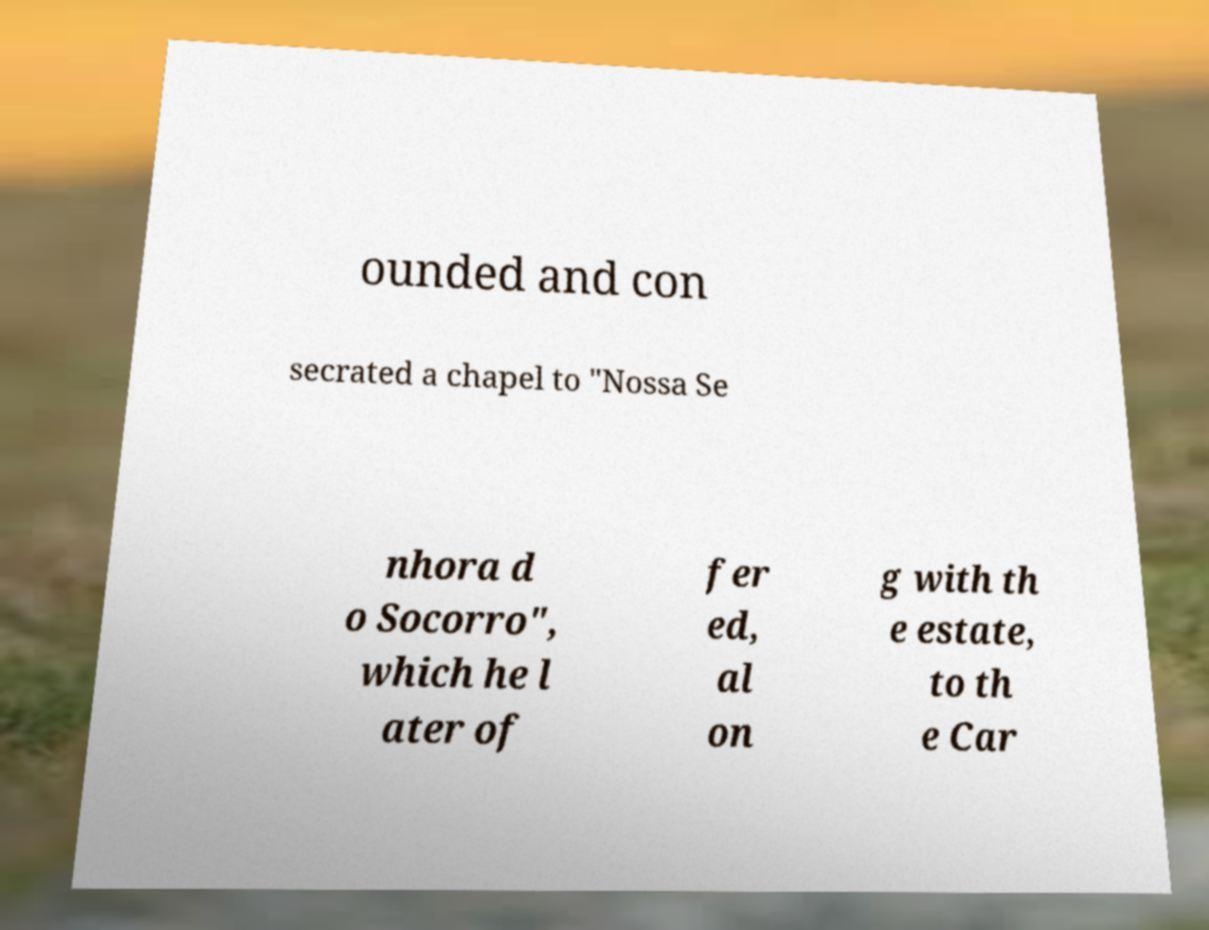Can you accurately transcribe the text from the provided image for me? ounded and con secrated a chapel to "Nossa Se nhora d o Socorro", which he l ater of fer ed, al on g with th e estate, to th e Car 